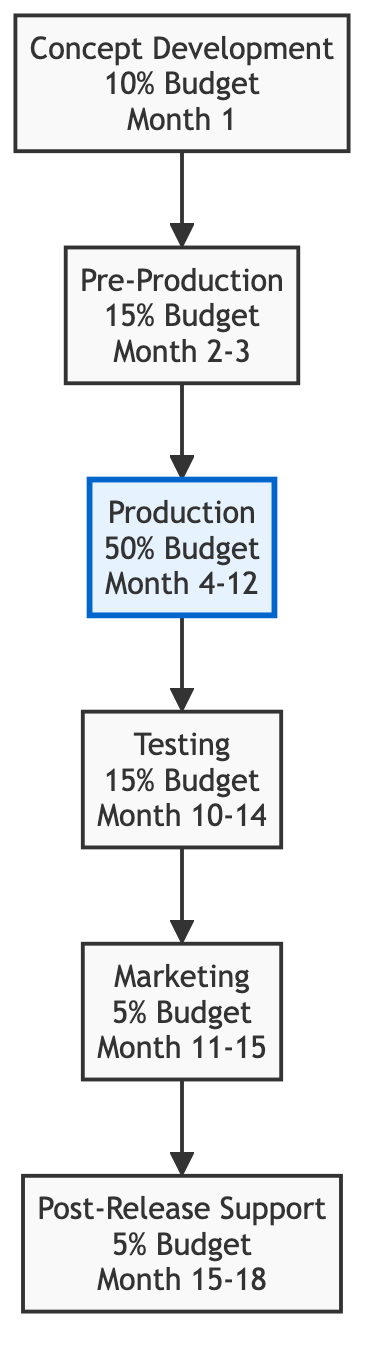What is the budget allocation for Production? The diagram shows that the budget allocation for Production is 50%, as indicated in the label for the Production node.
Answer: 50% How many total nodes are present in the diagram? Counting the nodes listed in the data, there are 6 distinct stages: Concept Development, Pre-Production, Production, Testing, Marketing, and Post-Release.
Answer: 6 What time frame does Marketing cover? The time frame for Marketing is specified in the node as Month 11-15. This detail is directly stated in the Marketing node's description.
Answer: Month 11-15 Which phase comes directly after Pre-Production? The edge connecting Pre-Production to Production indicates that Production is the next phase, as shown by the arrow in the diagram.
Answer: Production What percentage of the budget is allocated to Concept Development? The allocation for Concept Development is presented as 10% in the respective node's label.
Answer: 10% What is the total budget allocated for the phases before Testing? Adding the budget percentages for the phases before Testing, we have: 10% (Concept Development) + 15% (Pre-Production) + 50% (Production) = 75%. Hence, total budget for the phases before Testing is 75%.
Answer: 75% Which budget allocation represents the largest percentage? By reviewing the budget allocations, Production has the largest budget at 50%, making it the highest value compared to the other phases.
Answer: 50% During which months does Testing occur? The Testing phase is indicated to occur from Month 10 to Month 14 in the node dedicated to Testing.
Answer: Month 10-14 What is the last phase in the development process? The diagram indicates the flow of phases, which leads to Post-Release as the final stage, with no further nodes or edges following it.
Answer: Post-Release 